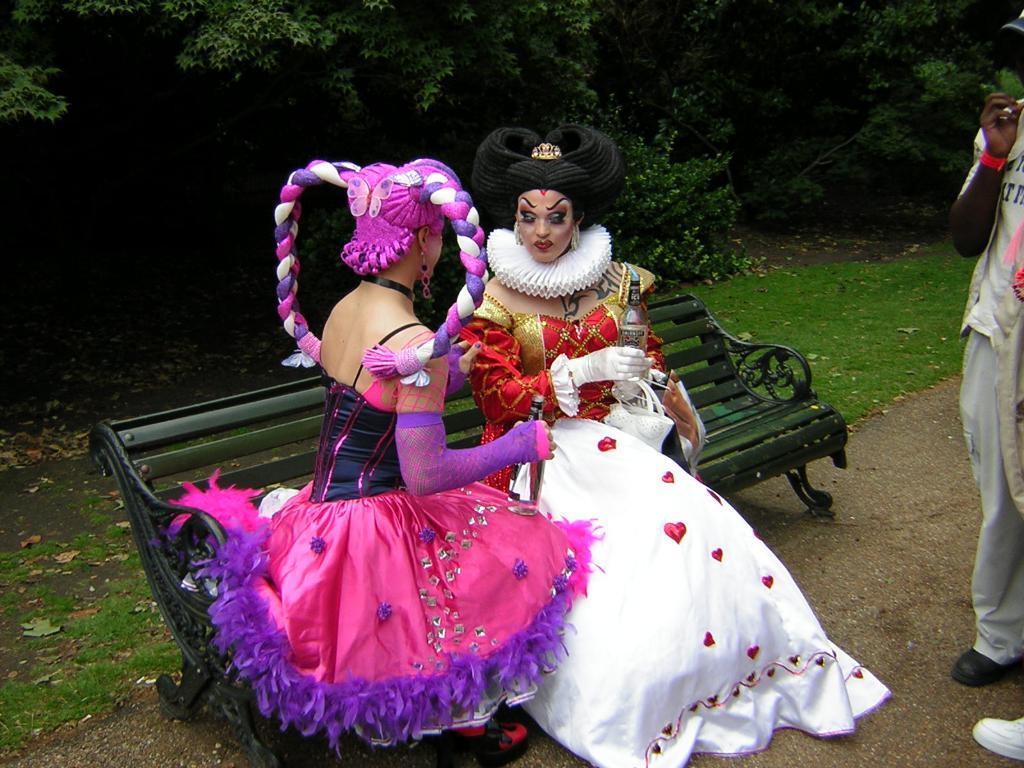Can you describe this image briefly? In the center of the image we can see two women sitting on the bench. On the right side of the image we can see a man standing on the road. In the background there are trees, plants and grass. 